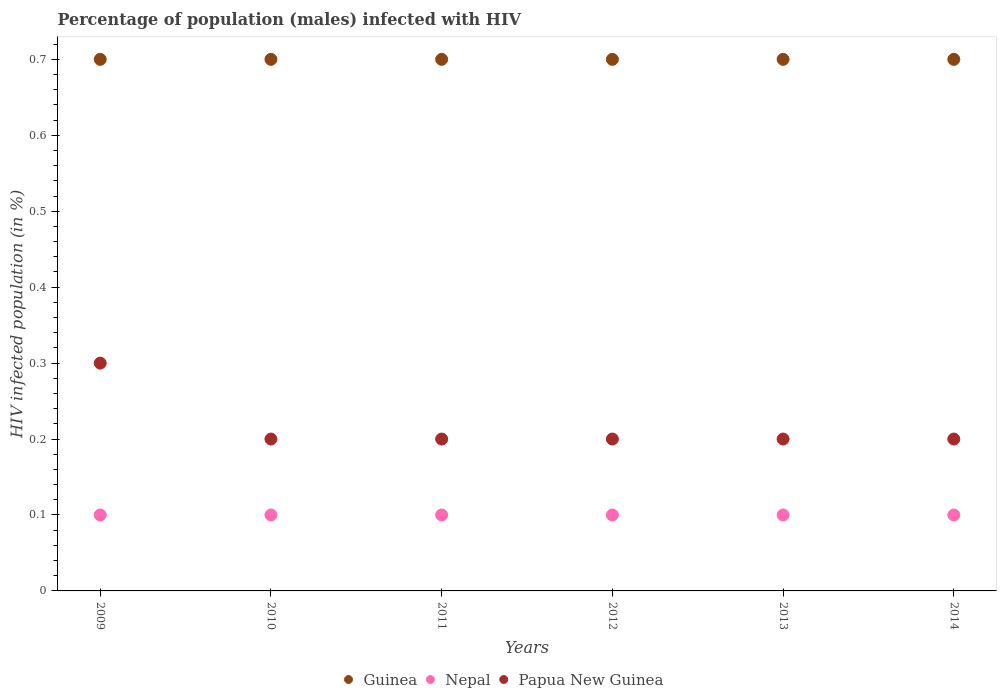Is the number of dotlines equal to the number of legend labels?
Offer a terse response. Yes. Across all years, what is the minimum percentage of HIV infected male population in Guinea?
Keep it short and to the point. 0.7. In which year was the percentage of HIV infected male population in Papua New Guinea maximum?
Your answer should be compact. 2009. What is the total percentage of HIV infected male population in Nepal in the graph?
Your answer should be compact. 0.6. What is the difference between the percentage of HIV infected male population in Guinea in 2011 and the percentage of HIV infected male population in Papua New Guinea in 2012?
Make the answer very short. 0.5. What is the average percentage of HIV infected male population in Nepal per year?
Offer a terse response. 0.1. In the year 2009, what is the difference between the percentage of HIV infected male population in Papua New Guinea and percentage of HIV infected male population in Guinea?
Offer a terse response. -0.4. Is the percentage of HIV infected male population in Nepal in 2009 less than that in 2012?
Ensure brevity in your answer.  No. Is the difference between the percentage of HIV infected male population in Papua New Guinea in 2009 and 2013 greater than the difference between the percentage of HIV infected male population in Guinea in 2009 and 2013?
Your answer should be compact. Yes. What is the difference between the highest and the lowest percentage of HIV infected male population in Nepal?
Make the answer very short. 0. In how many years, is the percentage of HIV infected male population in Nepal greater than the average percentage of HIV infected male population in Nepal taken over all years?
Your answer should be very brief. 6. Is it the case that in every year, the sum of the percentage of HIV infected male population in Guinea and percentage of HIV infected male population in Nepal  is greater than the percentage of HIV infected male population in Papua New Guinea?
Offer a terse response. Yes. Is the percentage of HIV infected male population in Nepal strictly greater than the percentage of HIV infected male population in Guinea over the years?
Provide a succinct answer. No. Is the percentage of HIV infected male population in Papua New Guinea strictly less than the percentage of HIV infected male population in Nepal over the years?
Make the answer very short. No. Are the values on the major ticks of Y-axis written in scientific E-notation?
Your answer should be very brief. No. Does the graph contain any zero values?
Make the answer very short. No. Where does the legend appear in the graph?
Your answer should be compact. Bottom center. How many legend labels are there?
Provide a short and direct response. 3. How are the legend labels stacked?
Your answer should be very brief. Horizontal. What is the title of the graph?
Offer a terse response. Percentage of population (males) infected with HIV. Does "Euro area" appear as one of the legend labels in the graph?
Your answer should be very brief. No. What is the label or title of the Y-axis?
Offer a very short reply. HIV infected population (in %). What is the HIV infected population (in %) of Nepal in 2010?
Offer a terse response. 0.1. What is the HIV infected population (in %) of Papua New Guinea in 2011?
Your answer should be very brief. 0.2. What is the HIV infected population (in %) of Guinea in 2012?
Provide a short and direct response. 0.7. What is the HIV infected population (in %) in Papua New Guinea in 2012?
Offer a terse response. 0.2. What is the HIV infected population (in %) of Nepal in 2013?
Provide a succinct answer. 0.1. What is the HIV infected population (in %) of Guinea in 2014?
Your response must be concise. 0.7. Across all years, what is the maximum HIV infected population (in %) in Nepal?
Provide a succinct answer. 0.1. Across all years, what is the minimum HIV infected population (in %) in Guinea?
Ensure brevity in your answer.  0.7. Across all years, what is the minimum HIV infected population (in %) in Papua New Guinea?
Your answer should be compact. 0.2. What is the total HIV infected population (in %) of Nepal in the graph?
Your answer should be compact. 0.6. What is the difference between the HIV infected population (in %) in Guinea in 2009 and that in 2010?
Provide a succinct answer. 0. What is the difference between the HIV infected population (in %) in Guinea in 2009 and that in 2012?
Offer a very short reply. 0. What is the difference between the HIV infected population (in %) in Nepal in 2009 and that in 2013?
Give a very brief answer. 0. What is the difference between the HIV infected population (in %) in Nepal in 2009 and that in 2014?
Offer a very short reply. 0. What is the difference between the HIV infected population (in %) of Papua New Guinea in 2010 and that in 2011?
Your answer should be very brief. 0. What is the difference between the HIV infected population (in %) in Guinea in 2010 and that in 2012?
Keep it short and to the point. 0. What is the difference between the HIV infected population (in %) in Guinea in 2010 and that in 2013?
Your response must be concise. 0. What is the difference between the HIV infected population (in %) in Nepal in 2010 and that in 2013?
Your response must be concise. 0. What is the difference between the HIV infected population (in %) of Papua New Guinea in 2010 and that in 2014?
Your response must be concise. 0. What is the difference between the HIV infected population (in %) of Nepal in 2011 and that in 2012?
Your response must be concise. 0. What is the difference between the HIV infected population (in %) of Guinea in 2011 and that in 2013?
Your answer should be very brief. 0. What is the difference between the HIV infected population (in %) in Nepal in 2011 and that in 2013?
Make the answer very short. 0. What is the difference between the HIV infected population (in %) in Guinea in 2011 and that in 2014?
Offer a terse response. 0. What is the difference between the HIV infected population (in %) of Guinea in 2012 and that in 2014?
Give a very brief answer. 0. What is the difference between the HIV infected population (in %) in Papua New Guinea in 2012 and that in 2014?
Your answer should be very brief. 0. What is the difference between the HIV infected population (in %) in Nepal in 2013 and that in 2014?
Make the answer very short. 0. What is the difference between the HIV infected population (in %) of Papua New Guinea in 2013 and that in 2014?
Provide a short and direct response. 0. What is the difference between the HIV infected population (in %) of Guinea in 2009 and the HIV infected population (in %) of Nepal in 2010?
Offer a very short reply. 0.6. What is the difference between the HIV infected population (in %) in Guinea in 2009 and the HIV infected population (in %) in Papua New Guinea in 2010?
Provide a short and direct response. 0.5. What is the difference between the HIV infected population (in %) in Nepal in 2009 and the HIV infected population (in %) in Papua New Guinea in 2010?
Provide a short and direct response. -0.1. What is the difference between the HIV infected population (in %) of Guinea in 2009 and the HIV infected population (in %) of Nepal in 2011?
Provide a short and direct response. 0.6. What is the difference between the HIV infected population (in %) of Nepal in 2009 and the HIV infected population (in %) of Papua New Guinea in 2012?
Offer a terse response. -0.1. What is the difference between the HIV infected population (in %) in Guinea in 2009 and the HIV infected population (in %) in Nepal in 2013?
Your answer should be very brief. 0.6. What is the difference between the HIV infected population (in %) in Guinea in 2009 and the HIV infected population (in %) in Papua New Guinea in 2013?
Offer a terse response. 0.5. What is the difference between the HIV infected population (in %) of Guinea in 2009 and the HIV infected population (in %) of Papua New Guinea in 2014?
Ensure brevity in your answer.  0.5. What is the difference between the HIV infected population (in %) in Nepal in 2009 and the HIV infected population (in %) in Papua New Guinea in 2014?
Your response must be concise. -0.1. What is the difference between the HIV infected population (in %) of Guinea in 2010 and the HIV infected population (in %) of Nepal in 2013?
Provide a succinct answer. 0.6. What is the difference between the HIV infected population (in %) of Guinea in 2010 and the HIV infected population (in %) of Nepal in 2014?
Offer a very short reply. 0.6. What is the difference between the HIV infected population (in %) in Guinea in 2010 and the HIV infected population (in %) in Papua New Guinea in 2014?
Ensure brevity in your answer.  0.5. What is the difference between the HIV infected population (in %) of Guinea in 2011 and the HIV infected population (in %) of Nepal in 2012?
Provide a succinct answer. 0.6. What is the difference between the HIV infected population (in %) of Guinea in 2011 and the HIV infected population (in %) of Papua New Guinea in 2012?
Provide a short and direct response. 0.5. What is the difference between the HIV infected population (in %) in Guinea in 2011 and the HIV infected population (in %) in Nepal in 2013?
Ensure brevity in your answer.  0.6. What is the difference between the HIV infected population (in %) of Guinea in 2011 and the HIV infected population (in %) of Papua New Guinea in 2013?
Your response must be concise. 0.5. What is the difference between the HIV infected population (in %) of Guinea in 2012 and the HIV infected population (in %) of Nepal in 2013?
Keep it short and to the point. 0.6. What is the difference between the HIV infected population (in %) of Nepal in 2012 and the HIV infected population (in %) of Papua New Guinea in 2013?
Offer a very short reply. -0.1. What is the difference between the HIV infected population (in %) of Guinea in 2012 and the HIV infected population (in %) of Nepal in 2014?
Offer a terse response. 0.6. What is the difference between the HIV infected population (in %) of Nepal in 2012 and the HIV infected population (in %) of Papua New Guinea in 2014?
Your answer should be very brief. -0.1. What is the difference between the HIV infected population (in %) in Guinea in 2013 and the HIV infected population (in %) in Nepal in 2014?
Make the answer very short. 0.6. What is the difference between the HIV infected population (in %) in Nepal in 2013 and the HIV infected population (in %) in Papua New Guinea in 2014?
Provide a short and direct response. -0.1. What is the average HIV infected population (in %) of Guinea per year?
Give a very brief answer. 0.7. What is the average HIV infected population (in %) of Nepal per year?
Make the answer very short. 0.1. What is the average HIV infected population (in %) in Papua New Guinea per year?
Your answer should be compact. 0.22. In the year 2009, what is the difference between the HIV infected population (in %) of Guinea and HIV infected population (in %) of Nepal?
Provide a succinct answer. 0.6. In the year 2009, what is the difference between the HIV infected population (in %) of Nepal and HIV infected population (in %) of Papua New Guinea?
Keep it short and to the point. -0.2. In the year 2011, what is the difference between the HIV infected population (in %) of Nepal and HIV infected population (in %) of Papua New Guinea?
Your answer should be very brief. -0.1. In the year 2012, what is the difference between the HIV infected population (in %) in Guinea and HIV infected population (in %) in Nepal?
Provide a succinct answer. 0.6. In the year 2012, what is the difference between the HIV infected population (in %) in Guinea and HIV infected population (in %) in Papua New Guinea?
Give a very brief answer. 0.5. In the year 2012, what is the difference between the HIV infected population (in %) in Nepal and HIV infected population (in %) in Papua New Guinea?
Offer a very short reply. -0.1. In the year 2013, what is the difference between the HIV infected population (in %) in Nepal and HIV infected population (in %) in Papua New Guinea?
Your answer should be compact. -0.1. In the year 2014, what is the difference between the HIV infected population (in %) in Guinea and HIV infected population (in %) in Nepal?
Offer a terse response. 0.6. In the year 2014, what is the difference between the HIV infected population (in %) in Guinea and HIV infected population (in %) in Papua New Guinea?
Provide a short and direct response. 0.5. What is the ratio of the HIV infected population (in %) in Nepal in 2009 to that in 2010?
Provide a succinct answer. 1. What is the ratio of the HIV infected population (in %) of Papua New Guinea in 2009 to that in 2010?
Make the answer very short. 1.5. What is the ratio of the HIV infected population (in %) of Nepal in 2009 to that in 2011?
Your response must be concise. 1. What is the ratio of the HIV infected population (in %) of Papua New Guinea in 2009 to that in 2011?
Ensure brevity in your answer.  1.5. What is the ratio of the HIV infected population (in %) of Nepal in 2009 to that in 2012?
Your response must be concise. 1. What is the ratio of the HIV infected population (in %) of Papua New Guinea in 2009 to that in 2012?
Give a very brief answer. 1.5. What is the ratio of the HIV infected population (in %) in Guinea in 2009 to that in 2013?
Ensure brevity in your answer.  1. What is the ratio of the HIV infected population (in %) in Nepal in 2009 to that in 2013?
Offer a very short reply. 1. What is the ratio of the HIV infected population (in %) of Nepal in 2009 to that in 2014?
Offer a very short reply. 1. What is the ratio of the HIV infected population (in %) of Guinea in 2010 to that in 2011?
Provide a short and direct response. 1. What is the ratio of the HIV infected population (in %) in Guinea in 2010 to that in 2012?
Your answer should be compact. 1. What is the ratio of the HIV infected population (in %) of Nepal in 2010 to that in 2012?
Provide a succinct answer. 1. What is the ratio of the HIV infected population (in %) in Papua New Guinea in 2010 to that in 2012?
Give a very brief answer. 1. What is the ratio of the HIV infected population (in %) of Guinea in 2010 to that in 2014?
Offer a terse response. 1. What is the ratio of the HIV infected population (in %) of Nepal in 2010 to that in 2014?
Make the answer very short. 1. What is the ratio of the HIV infected population (in %) of Papua New Guinea in 2010 to that in 2014?
Provide a short and direct response. 1. What is the ratio of the HIV infected population (in %) in Guinea in 2011 to that in 2012?
Your answer should be compact. 1. What is the ratio of the HIV infected population (in %) in Guinea in 2011 to that in 2013?
Keep it short and to the point. 1. What is the ratio of the HIV infected population (in %) in Papua New Guinea in 2011 to that in 2013?
Keep it short and to the point. 1. What is the ratio of the HIV infected population (in %) of Guinea in 2011 to that in 2014?
Provide a short and direct response. 1. What is the ratio of the HIV infected population (in %) of Nepal in 2012 to that in 2013?
Your answer should be compact. 1. What is the ratio of the HIV infected population (in %) of Papua New Guinea in 2012 to that in 2013?
Your response must be concise. 1. What is the ratio of the HIV infected population (in %) in Guinea in 2012 to that in 2014?
Your answer should be very brief. 1. What is the ratio of the HIV infected population (in %) in Nepal in 2013 to that in 2014?
Make the answer very short. 1. What is the difference between the highest and the second highest HIV infected population (in %) of Guinea?
Your response must be concise. 0. What is the difference between the highest and the second highest HIV infected population (in %) in Nepal?
Provide a succinct answer. 0. What is the difference between the highest and the second highest HIV infected population (in %) of Papua New Guinea?
Your answer should be very brief. 0.1. What is the difference between the highest and the lowest HIV infected population (in %) in Papua New Guinea?
Provide a short and direct response. 0.1. 